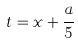<formula> <loc_0><loc_0><loc_500><loc_500>t = x + \frac { a } { 5 }</formula> 